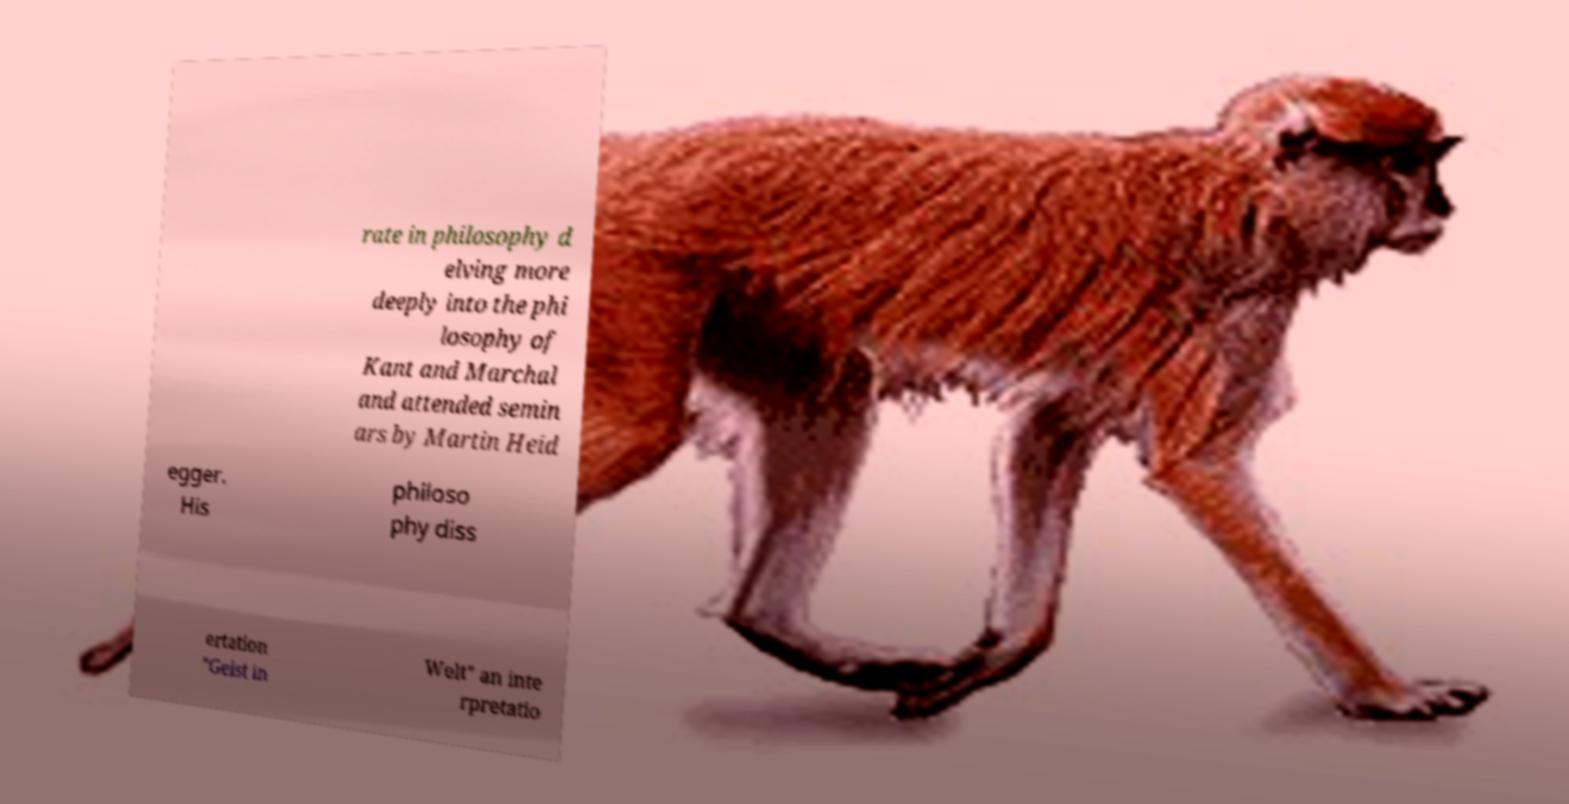Please read and relay the text visible in this image. What does it say? rate in philosophy d elving more deeply into the phi losophy of Kant and Marchal and attended semin ars by Martin Heid egger. His philoso phy diss ertation "Geist in Welt" an inte rpretatio 